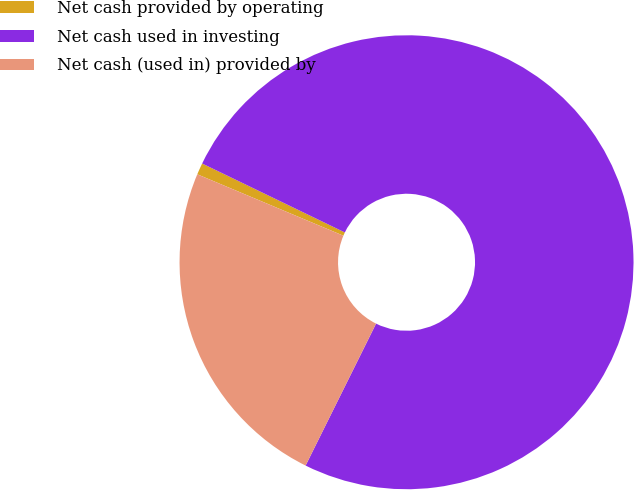Convert chart. <chart><loc_0><loc_0><loc_500><loc_500><pie_chart><fcel>Net cash provided by operating<fcel>Net cash used in investing<fcel>Net cash (used in) provided by<nl><fcel>0.83%<fcel>75.17%<fcel>24.0%<nl></chart> 